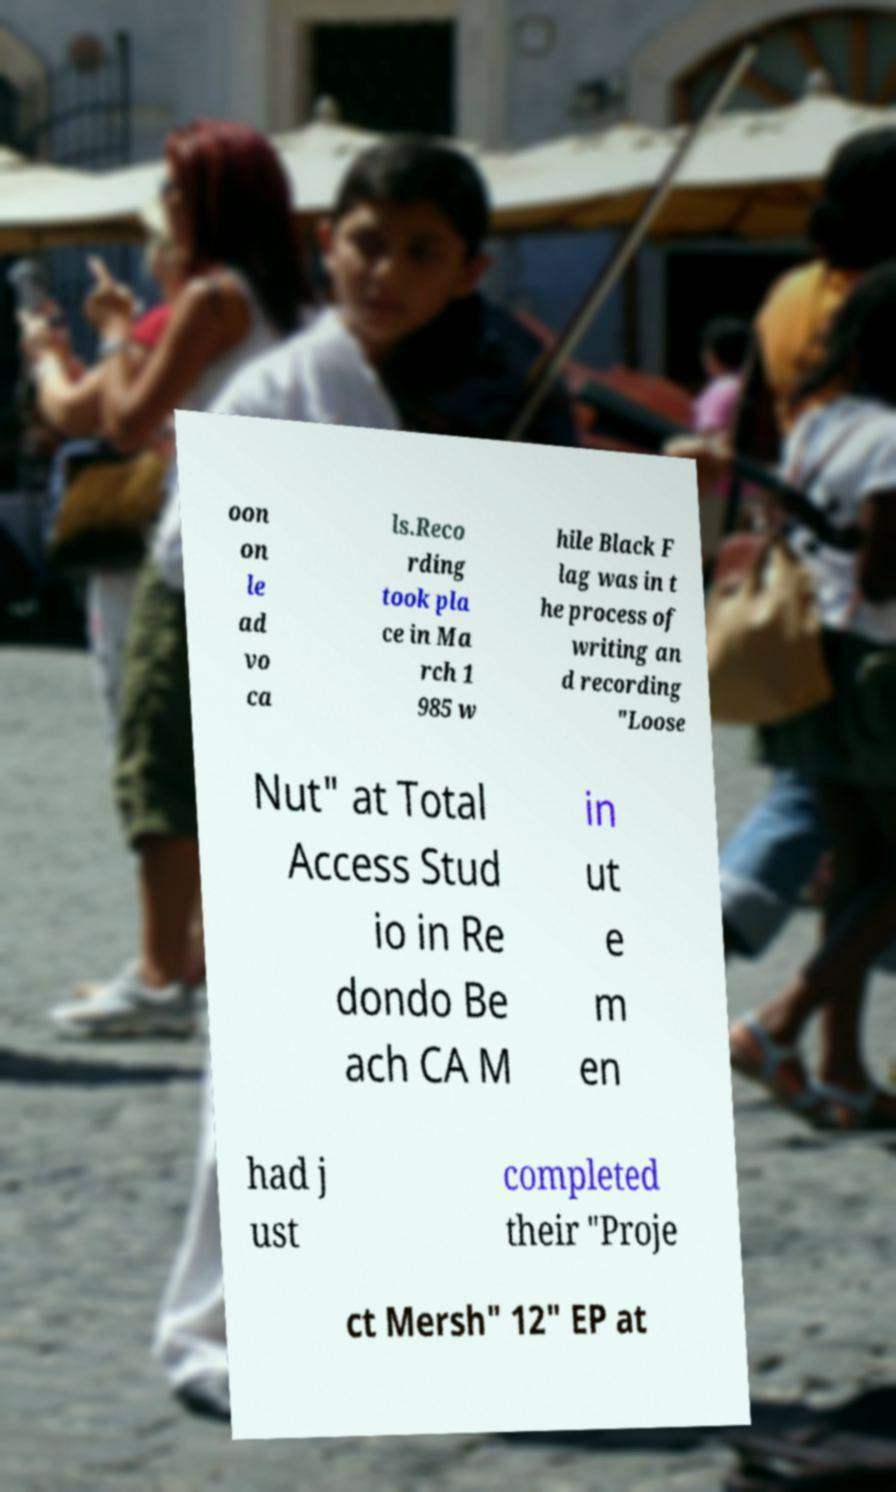Can you accurately transcribe the text from the provided image for me? oon on le ad vo ca ls.Reco rding took pla ce in Ma rch 1 985 w hile Black F lag was in t he process of writing an d recording "Loose Nut" at Total Access Stud io in Re dondo Be ach CA M in ut e m en had j ust completed their "Proje ct Mersh" 12" EP at 